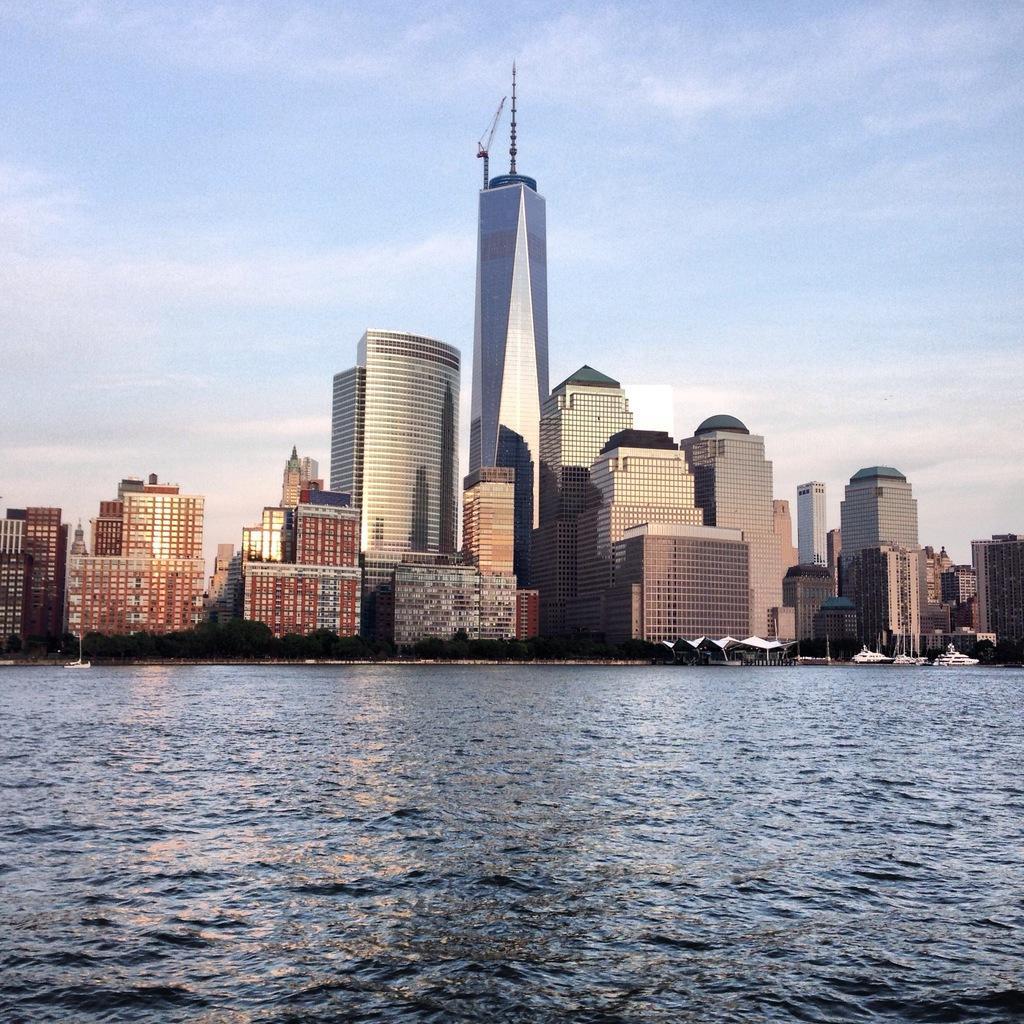Describe this image in one or two sentences. This image is taken outdoors. At the bottom of the image there is a sea. At the top of the image there is a sky with clouds. In the middle of the image there are many buildings and skyscrapers with walls, windows, doors, roofs, railings and balconies and there are a few trees and ships. 